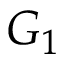<formula> <loc_0><loc_0><loc_500><loc_500>G _ { 1 }</formula> 